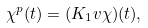<formula> <loc_0><loc_0><loc_500><loc_500>\chi ^ { p } ( t ) = ( K _ { 1 } v \chi ) ( t ) ,</formula> 